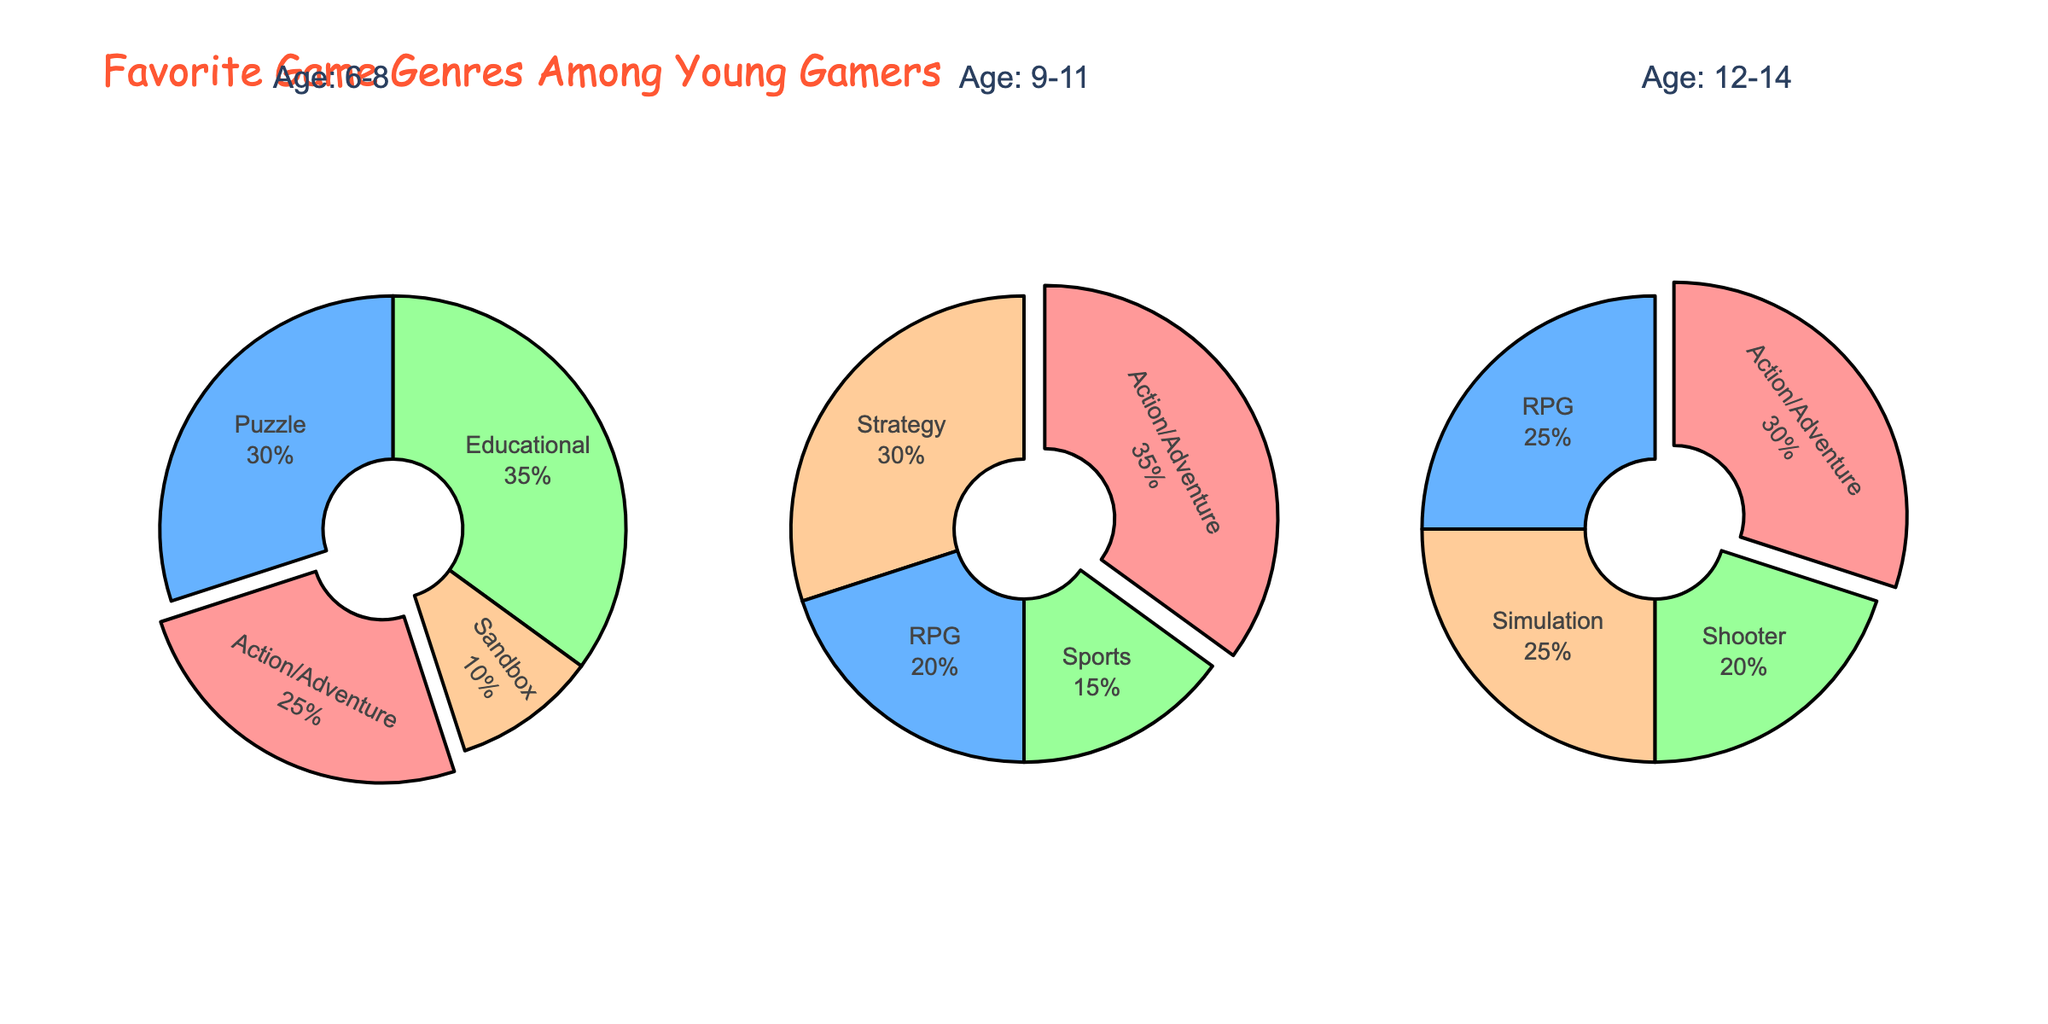What are the titles of the subplots? The titles of the subplots are located at the top and they correspond to the age groups: "6-8", "9-11", and "12-14".
Answer: "6-8", "9-11", and "12-14" Which genre is most popular among gamers aged 6-8? The largest section of the pie chart for the 6-8 age group represents "Educational" games, with 35%.
Answer: Educational How does the popularity of Action/Adventure games change across the three age groups? For the age group 6-8, it is 25%. For 9-11, it increases to 35%. For 12-14, it decreases slightly to 30%.
Answer: Increases, then decreases Which age group shows the highest preference for RPG games? The pie chart for the age group 12-14 shows 25% for RPG, which is higher compared to 20% in the 9-11 age group. The 6-8 age group does not show RPG as a genre.
Answer: 12-14 What percentage of gamers aged 9-11 prefer Sports games? The pie chart for the age group 9-11 indicates that 15% of gamers prefer Sports games.
Answer: 15% If you combine the percentages of Strategy and RPG games for the 9-11 age group, what do you get? For the 9-11 age group, Strategy is 30% and RPG is 20%. Adding these together gives 30% + 20% = 50%.
Answer: 50% Which genre is least popular among gamers aged 6-8? The smallest section of the pie chart for the 6-8 age group represents "Sandbox" games, with 10%.
Answer: Sandbox Which age group features the Shooter genre? Only the 12-14 age group pie chart includes the "Shooter" genre, representing 20%.
Answer: 12-14 What is the total percentage of simulation games across all age groups? The 6-8 and 9-11 age groups do not include Simulation games. However, the 12-14 age group chart shows Simulation at 25%, so the total percentage is 25%.
Answer: 25% For the age group 12-14, does any game genre share the same percentage? Yes, in the 12-14 age group, both RPG and Simulation have 25%.
Answer: Yes 